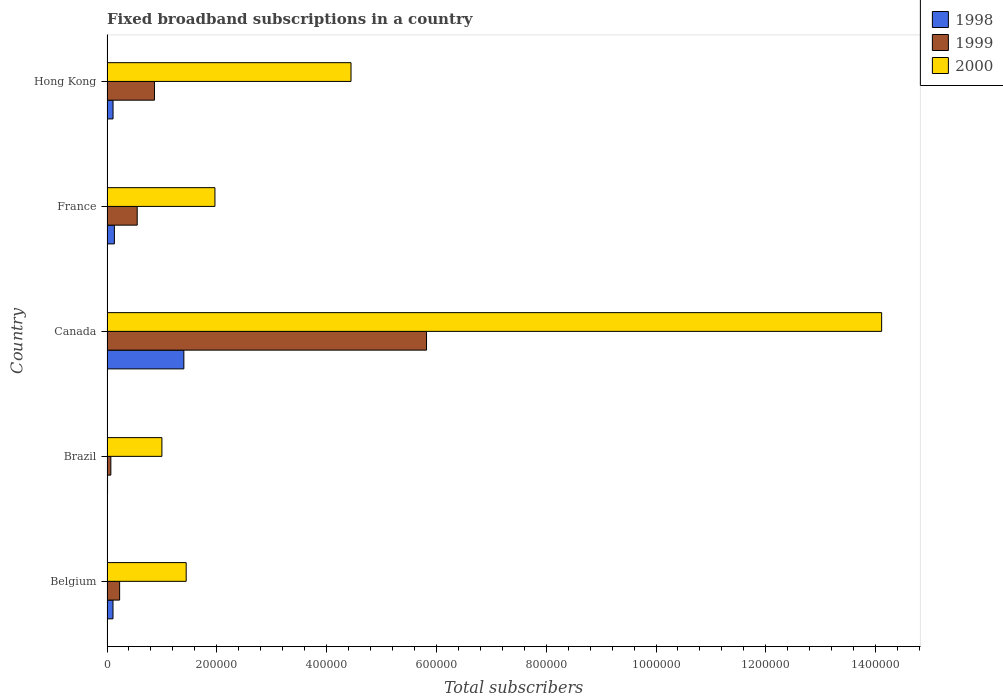What is the number of broadband subscriptions in 1998 in France?
Your answer should be very brief. 1.35e+04. Across all countries, what is the maximum number of broadband subscriptions in 1999?
Provide a short and direct response. 5.82e+05. Across all countries, what is the minimum number of broadband subscriptions in 1999?
Offer a very short reply. 7000. In which country was the number of broadband subscriptions in 2000 maximum?
Ensure brevity in your answer.  Canada. What is the total number of broadband subscriptions in 1998 in the graph?
Give a very brief answer. 1.76e+05. What is the difference between the number of broadband subscriptions in 1999 in Brazil and that in Canada?
Offer a terse response. -5.75e+05. What is the difference between the number of broadband subscriptions in 2000 in France and the number of broadband subscriptions in 1998 in Belgium?
Your response must be concise. 1.86e+05. What is the average number of broadband subscriptions in 2000 per country?
Offer a terse response. 4.59e+05. What is the difference between the number of broadband subscriptions in 2000 and number of broadband subscriptions in 1998 in Belgium?
Your answer should be very brief. 1.33e+05. What is the ratio of the number of broadband subscriptions in 1998 in Brazil to that in Hong Kong?
Your answer should be compact. 0.09. Is the number of broadband subscriptions in 1998 in Belgium less than that in Hong Kong?
Your answer should be very brief. Yes. Is the difference between the number of broadband subscriptions in 2000 in France and Hong Kong greater than the difference between the number of broadband subscriptions in 1998 in France and Hong Kong?
Your answer should be compact. No. What is the difference between the highest and the second highest number of broadband subscriptions in 2000?
Ensure brevity in your answer.  9.66e+05. What is the difference between the highest and the lowest number of broadband subscriptions in 1998?
Make the answer very short. 1.39e+05. In how many countries, is the number of broadband subscriptions in 1999 greater than the average number of broadband subscriptions in 1999 taken over all countries?
Make the answer very short. 1. Is it the case that in every country, the sum of the number of broadband subscriptions in 1999 and number of broadband subscriptions in 2000 is greater than the number of broadband subscriptions in 1998?
Your answer should be very brief. Yes. Are all the bars in the graph horizontal?
Offer a very short reply. Yes. Does the graph contain any zero values?
Make the answer very short. No. Does the graph contain grids?
Your answer should be compact. No. How are the legend labels stacked?
Offer a very short reply. Vertical. What is the title of the graph?
Offer a terse response. Fixed broadband subscriptions in a country. What is the label or title of the X-axis?
Provide a short and direct response. Total subscribers. What is the label or title of the Y-axis?
Provide a short and direct response. Country. What is the Total subscribers in 1998 in Belgium?
Your answer should be compact. 1.09e+04. What is the Total subscribers in 1999 in Belgium?
Offer a terse response. 2.30e+04. What is the Total subscribers of 2000 in Belgium?
Your answer should be compact. 1.44e+05. What is the Total subscribers of 1998 in Brazil?
Keep it short and to the point. 1000. What is the Total subscribers in 1999 in Brazil?
Provide a succinct answer. 7000. What is the Total subscribers in 2000 in Brazil?
Your answer should be very brief. 1.00e+05. What is the Total subscribers of 1999 in Canada?
Give a very brief answer. 5.82e+05. What is the Total subscribers in 2000 in Canada?
Your response must be concise. 1.41e+06. What is the Total subscribers in 1998 in France?
Your answer should be very brief. 1.35e+04. What is the Total subscribers in 1999 in France?
Provide a short and direct response. 5.50e+04. What is the Total subscribers in 2000 in France?
Make the answer very short. 1.97e+05. What is the Total subscribers of 1998 in Hong Kong?
Provide a succinct answer. 1.10e+04. What is the Total subscribers in 1999 in Hong Kong?
Ensure brevity in your answer.  8.65e+04. What is the Total subscribers in 2000 in Hong Kong?
Give a very brief answer. 4.44e+05. Across all countries, what is the maximum Total subscribers of 1998?
Ensure brevity in your answer.  1.40e+05. Across all countries, what is the maximum Total subscribers in 1999?
Give a very brief answer. 5.82e+05. Across all countries, what is the maximum Total subscribers in 2000?
Give a very brief answer. 1.41e+06. Across all countries, what is the minimum Total subscribers of 1999?
Offer a very short reply. 7000. Across all countries, what is the minimum Total subscribers in 2000?
Offer a terse response. 1.00e+05. What is the total Total subscribers in 1998 in the graph?
Offer a terse response. 1.76e+05. What is the total Total subscribers in 1999 in the graph?
Your response must be concise. 7.53e+05. What is the total Total subscribers in 2000 in the graph?
Give a very brief answer. 2.30e+06. What is the difference between the Total subscribers in 1998 in Belgium and that in Brazil?
Offer a very short reply. 9924. What is the difference between the Total subscribers of 1999 in Belgium and that in Brazil?
Your answer should be compact. 1.60e+04. What is the difference between the Total subscribers of 2000 in Belgium and that in Brazil?
Offer a very short reply. 4.42e+04. What is the difference between the Total subscribers in 1998 in Belgium and that in Canada?
Give a very brief answer. -1.29e+05. What is the difference between the Total subscribers of 1999 in Belgium and that in Canada?
Your answer should be very brief. -5.59e+05. What is the difference between the Total subscribers in 2000 in Belgium and that in Canada?
Your answer should be very brief. -1.27e+06. What is the difference between the Total subscribers in 1998 in Belgium and that in France?
Your response must be concise. -2540. What is the difference between the Total subscribers of 1999 in Belgium and that in France?
Offer a terse response. -3.20e+04. What is the difference between the Total subscribers of 2000 in Belgium and that in France?
Offer a terse response. -5.24e+04. What is the difference between the Total subscribers in 1998 in Belgium and that in Hong Kong?
Offer a terse response. -76. What is the difference between the Total subscribers in 1999 in Belgium and that in Hong Kong?
Keep it short and to the point. -6.35e+04. What is the difference between the Total subscribers in 2000 in Belgium and that in Hong Kong?
Give a very brief answer. -3.00e+05. What is the difference between the Total subscribers of 1998 in Brazil and that in Canada?
Provide a short and direct response. -1.39e+05. What is the difference between the Total subscribers of 1999 in Brazil and that in Canada?
Your answer should be very brief. -5.75e+05. What is the difference between the Total subscribers in 2000 in Brazil and that in Canada?
Offer a terse response. -1.31e+06. What is the difference between the Total subscribers in 1998 in Brazil and that in France?
Keep it short and to the point. -1.25e+04. What is the difference between the Total subscribers of 1999 in Brazil and that in France?
Make the answer very short. -4.80e+04. What is the difference between the Total subscribers of 2000 in Brazil and that in France?
Give a very brief answer. -9.66e+04. What is the difference between the Total subscribers of 1999 in Brazil and that in Hong Kong?
Provide a succinct answer. -7.95e+04. What is the difference between the Total subscribers in 2000 in Brazil and that in Hong Kong?
Your response must be concise. -3.44e+05. What is the difference between the Total subscribers of 1998 in Canada and that in France?
Provide a short and direct response. 1.27e+05. What is the difference between the Total subscribers of 1999 in Canada and that in France?
Offer a terse response. 5.27e+05. What is the difference between the Total subscribers of 2000 in Canada and that in France?
Your answer should be compact. 1.21e+06. What is the difference between the Total subscribers in 1998 in Canada and that in Hong Kong?
Your answer should be compact. 1.29e+05. What is the difference between the Total subscribers of 1999 in Canada and that in Hong Kong?
Give a very brief answer. 4.96e+05. What is the difference between the Total subscribers of 2000 in Canada and that in Hong Kong?
Give a very brief answer. 9.66e+05. What is the difference between the Total subscribers of 1998 in France and that in Hong Kong?
Provide a short and direct response. 2464. What is the difference between the Total subscribers of 1999 in France and that in Hong Kong?
Your answer should be compact. -3.15e+04. What is the difference between the Total subscribers in 2000 in France and that in Hong Kong?
Make the answer very short. -2.48e+05. What is the difference between the Total subscribers in 1998 in Belgium and the Total subscribers in 1999 in Brazil?
Provide a succinct answer. 3924. What is the difference between the Total subscribers of 1998 in Belgium and the Total subscribers of 2000 in Brazil?
Ensure brevity in your answer.  -8.91e+04. What is the difference between the Total subscribers in 1999 in Belgium and the Total subscribers in 2000 in Brazil?
Provide a short and direct response. -7.70e+04. What is the difference between the Total subscribers in 1998 in Belgium and the Total subscribers in 1999 in Canada?
Provide a succinct answer. -5.71e+05. What is the difference between the Total subscribers in 1998 in Belgium and the Total subscribers in 2000 in Canada?
Your answer should be very brief. -1.40e+06. What is the difference between the Total subscribers in 1999 in Belgium and the Total subscribers in 2000 in Canada?
Keep it short and to the point. -1.39e+06. What is the difference between the Total subscribers in 1998 in Belgium and the Total subscribers in 1999 in France?
Provide a succinct answer. -4.41e+04. What is the difference between the Total subscribers in 1998 in Belgium and the Total subscribers in 2000 in France?
Your answer should be compact. -1.86e+05. What is the difference between the Total subscribers in 1999 in Belgium and the Total subscribers in 2000 in France?
Give a very brief answer. -1.74e+05. What is the difference between the Total subscribers of 1998 in Belgium and the Total subscribers of 1999 in Hong Kong?
Provide a succinct answer. -7.55e+04. What is the difference between the Total subscribers in 1998 in Belgium and the Total subscribers in 2000 in Hong Kong?
Give a very brief answer. -4.34e+05. What is the difference between the Total subscribers of 1999 in Belgium and the Total subscribers of 2000 in Hong Kong?
Your response must be concise. -4.21e+05. What is the difference between the Total subscribers in 1998 in Brazil and the Total subscribers in 1999 in Canada?
Give a very brief answer. -5.81e+05. What is the difference between the Total subscribers in 1998 in Brazil and the Total subscribers in 2000 in Canada?
Your response must be concise. -1.41e+06. What is the difference between the Total subscribers of 1999 in Brazil and the Total subscribers of 2000 in Canada?
Your answer should be compact. -1.40e+06. What is the difference between the Total subscribers in 1998 in Brazil and the Total subscribers in 1999 in France?
Offer a terse response. -5.40e+04. What is the difference between the Total subscribers of 1998 in Brazil and the Total subscribers of 2000 in France?
Provide a succinct answer. -1.96e+05. What is the difference between the Total subscribers of 1999 in Brazil and the Total subscribers of 2000 in France?
Make the answer very short. -1.90e+05. What is the difference between the Total subscribers of 1998 in Brazil and the Total subscribers of 1999 in Hong Kong?
Offer a very short reply. -8.55e+04. What is the difference between the Total subscribers of 1998 in Brazil and the Total subscribers of 2000 in Hong Kong?
Make the answer very short. -4.43e+05. What is the difference between the Total subscribers in 1999 in Brazil and the Total subscribers in 2000 in Hong Kong?
Your answer should be compact. -4.37e+05. What is the difference between the Total subscribers in 1998 in Canada and the Total subscribers in 1999 in France?
Offer a terse response. 8.50e+04. What is the difference between the Total subscribers in 1998 in Canada and the Total subscribers in 2000 in France?
Ensure brevity in your answer.  -5.66e+04. What is the difference between the Total subscribers in 1999 in Canada and the Total subscribers in 2000 in France?
Offer a terse response. 3.85e+05. What is the difference between the Total subscribers of 1998 in Canada and the Total subscribers of 1999 in Hong Kong?
Offer a very short reply. 5.35e+04. What is the difference between the Total subscribers in 1998 in Canada and the Total subscribers in 2000 in Hong Kong?
Provide a succinct answer. -3.04e+05. What is the difference between the Total subscribers in 1999 in Canada and the Total subscribers in 2000 in Hong Kong?
Keep it short and to the point. 1.38e+05. What is the difference between the Total subscribers of 1998 in France and the Total subscribers of 1999 in Hong Kong?
Give a very brief answer. -7.30e+04. What is the difference between the Total subscribers in 1998 in France and the Total subscribers in 2000 in Hong Kong?
Provide a succinct answer. -4.31e+05. What is the difference between the Total subscribers of 1999 in France and the Total subscribers of 2000 in Hong Kong?
Offer a very short reply. -3.89e+05. What is the average Total subscribers of 1998 per country?
Give a very brief answer. 3.53e+04. What is the average Total subscribers of 1999 per country?
Provide a short and direct response. 1.51e+05. What is the average Total subscribers of 2000 per country?
Offer a very short reply. 4.59e+05. What is the difference between the Total subscribers in 1998 and Total subscribers in 1999 in Belgium?
Offer a very short reply. -1.21e+04. What is the difference between the Total subscribers of 1998 and Total subscribers of 2000 in Belgium?
Keep it short and to the point. -1.33e+05. What is the difference between the Total subscribers of 1999 and Total subscribers of 2000 in Belgium?
Give a very brief answer. -1.21e+05. What is the difference between the Total subscribers in 1998 and Total subscribers in 1999 in Brazil?
Ensure brevity in your answer.  -6000. What is the difference between the Total subscribers of 1998 and Total subscribers of 2000 in Brazil?
Provide a short and direct response. -9.90e+04. What is the difference between the Total subscribers of 1999 and Total subscribers of 2000 in Brazil?
Keep it short and to the point. -9.30e+04. What is the difference between the Total subscribers in 1998 and Total subscribers in 1999 in Canada?
Provide a succinct answer. -4.42e+05. What is the difference between the Total subscribers of 1998 and Total subscribers of 2000 in Canada?
Provide a succinct answer. -1.27e+06. What is the difference between the Total subscribers of 1999 and Total subscribers of 2000 in Canada?
Give a very brief answer. -8.29e+05. What is the difference between the Total subscribers of 1998 and Total subscribers of 1999 in France?
Keep it short and to the point. -4.15e+04. What is the difference between the Total subscribers of 1998 and Total subscribers of 2000 in France?
Keep it short and to the point. -1.83e+05. What is the difference between the Total subscribers in 1999 and Total subscribers in 2000 in France?
Keep it short and to the point. -1.42e+05. What is the difference between the Total subscribers in 1998 and Total subscribers in 1999 in Hong Kong?
Provide a short and direct response. -7.55e+04. What is the difference between the Total subscribers of 1998 and Total subscribers of 2000 in Hong Kong?
Your answer should be very brief. -4.33e+05. What is the difference between the Total subscribers of 1999 and Total subscribers of 2000 in Hong Kong?
Give a very brief answer. -3.58e+05. What is the ratio of the Total subscribers in 1998 in Belgium to that in Brazil?
Provide a succinct answer. 10.92. What is the ratio of the Total subscribers in 1999 in Belgium to that in Brazil?
Your answer should be very brief. 3.29. What is the ratio of the Total subscribers of 2000 in Belgium to that in Brazil?
Ensure brevity in your answer.  1.44. What is the ratio of the Total subscribers of 1998 in Belgium to that in Canada?
Make the answer very short. 0.08. What is the ratio of the Total subscribers of 1999 in Belgium to that in Canada?
Ensure brevity in your answer.  0.04. What is the ratio of the Total subscribers of 2000 in Belgium to that in Canada?
Ensure brevity in your answer.  0.1. What is the ratio of the Total subscribers in 1998 in Belgium to that in France?
Ensure brevity in your answer.  0.81. What is the ratio of the Total subscribers of 1999 in Belgium to that in France?
Your answer should be very brief. 0.42. What is the ratio of the Total subscribers in 2000 in Belgium to that in France?
Offer a terse response. 0.73. What is the ratio of the Total subscribers of 1998 in Belgium to that in Hong Kong?
Your answer should be compact. 0.99. What is the ratio of the Total subscribers of 1999 in Belgium to that in Hong Kong?
Your answer should be very brief. 0.27. What is the ratio of the Total subscribers in 2000 in Belgium to that in Hong Kong?
Ensure brevity in your answer.  0.32. What is the ratio of the Total subscribers of 1998 in Brazil to that in Canada?
Offer a very short reply. 0.01. What is the ratio of the Total subscribers in 1999 in Brazil to that in Canada?
Give a very brief answer. 0.01. What is the ratio of the Total subscribers in 2000 in Brazil to that in Canada?
Make the answer very short. 0.07. What is the ratio of the Total subscribers of 1998 in Brazil to that in France?
Offer a terse response. 0.07. What is the ratio of the Total subscribers in 1999 in Brazil to that in France?
Ensure brevity in your answer.  0.13. What is the ratio of the Total subscribers of 2000 in Brazil to that in France?
Offer a very short reply. 0.51. What is the ratio of the Total subscribers of 1998 in Brazil to that in Hong Kong?
Your response must be concise. 0.09. What is the ratio of the Total subscribers of 1999 in Brazil to that in Hong Kong?
Keep it short and to the point. 0.08. What is the ratio of the Total subscribers in 2000 in Brazil to that in Hong Kong?
Your answer should be very brief. 0.23. What is the ratio of the Total subscribers in 1998 in Canada to that in France?
Your response must be concise. 10.4. What is the ratio of the Total subscribers of 1999 in Canada to that in France?
Make the answer very short. 10.58. What is the ratio of the Total subscribers in 2000 in Canada to that in France?
Provide a short and direct response. 7.18. What is the ratio of the Total subscribers of 1998 in Canada to that in Hong Kong?
Make the answer very short. 12.73. What is the ratio of the Total subscribers of 1999 in Canada to that in Hong Kong?
Your response must be concise. 6.73. What is the ratio of the Total subscribers of 2000 in Canada to that in Hong Kong?
Make the answer very short. 3.17. What is the ratio of the Total subscribers in 1998 in France to that in Hong Kong?
Give a very brief answer. 1.22. What is the ratio of the Total subscribers of 1999 in France to that in Hong Kong?
Your response must be concise. 0.64. What is the ratio of the Total subscribers in 2000 in France to that in Hong Kong?
Your answer should be very brief. 0.44. What is the difference between the highest and the second highest Total subscribers of 1998?
Provide a succinct answer. 1.27e+05. What is the difference between the highest and the second highest Total subscribers in 1999?
Your answer should be very brief. 4.96e+05. What is the difference between the highest and the second highest Total subscribers in 2000?
Provide a succinct answer. 9.66e+05. What is the difference between the highest and the lowest Total subscribers of 1998?
Ensure brevity in your answer.  1.39e+05. What is the difference between the highest and the lowest Total subscribers in 1999?
Your response must be concise. 5.75e+05. What is the difference between the highest and the lowest Total subscribers in 2000?
Give a very brief answer. 1.31e+06. 